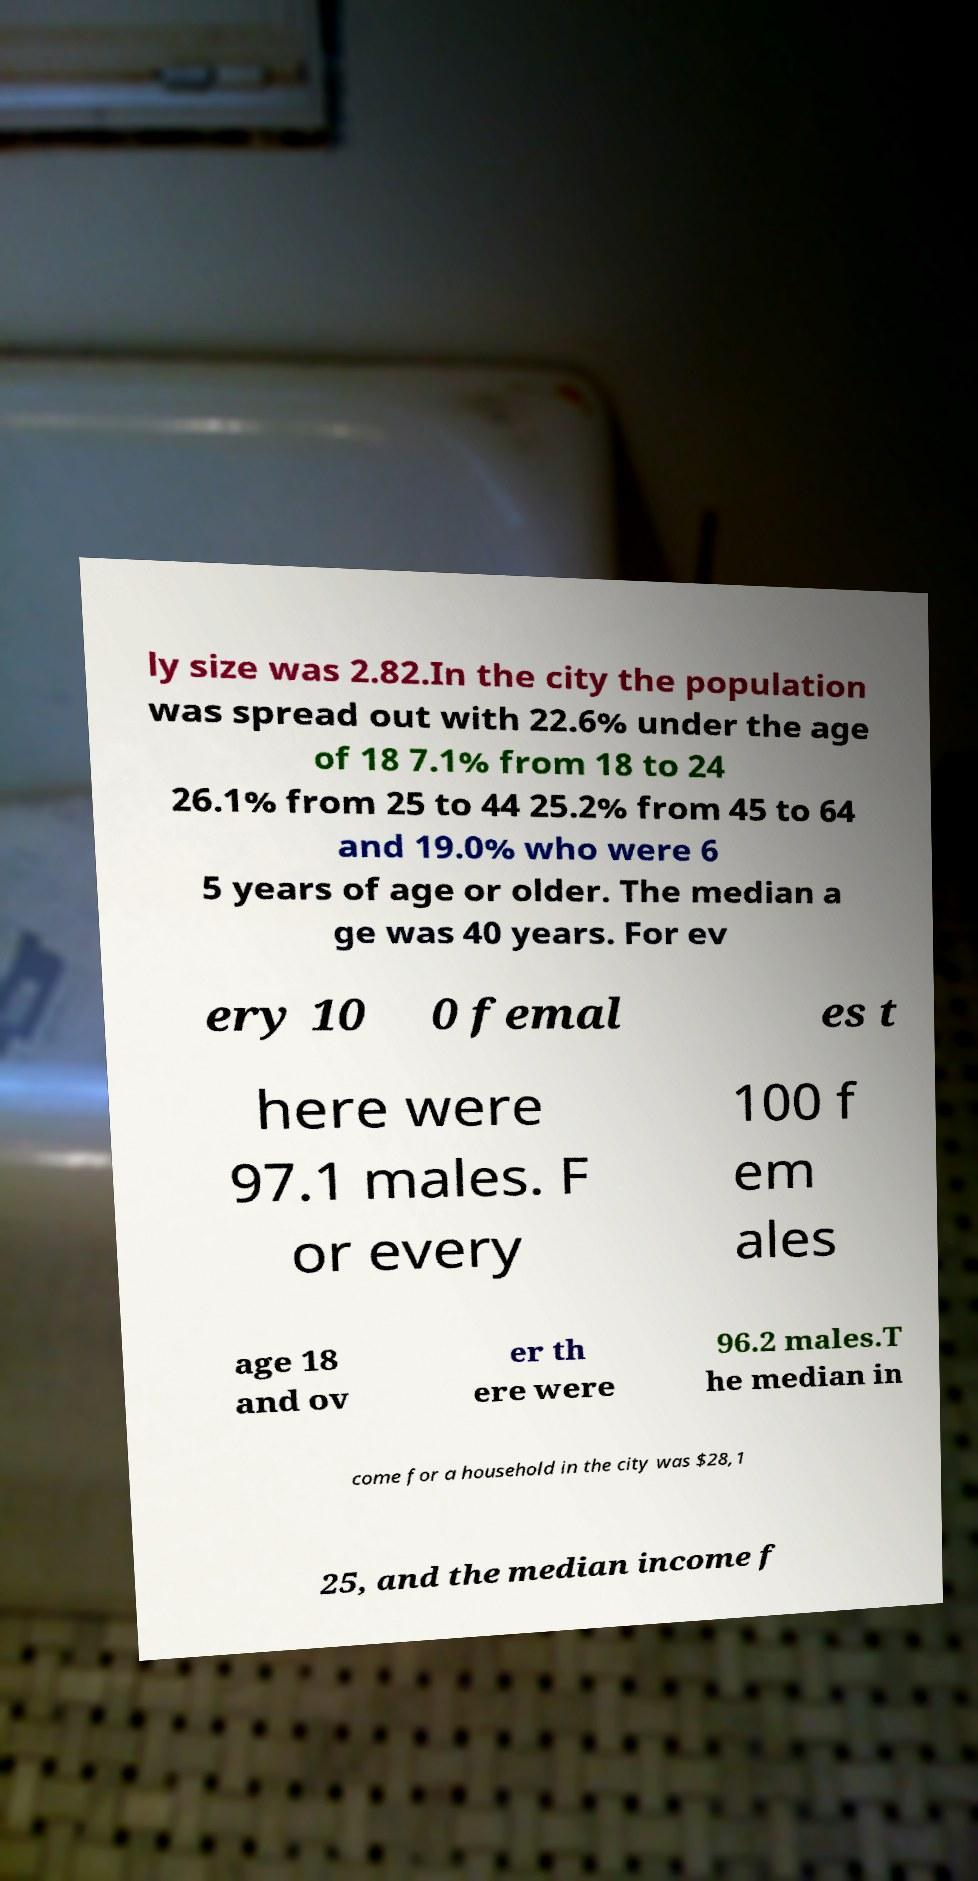Could you extract and type out the text from this image? ly size was 2.82.In the city the population was spread out with 22.6% under the age of 18 7.1% from 18 to 24 26.1% from 25 to 44 25.2% from 45 to 64 and 19.0% who were 6 5 years of age or older. The median a ge was 40 years. For ev ery 10 0 femal es t here were 97.1 males. F or every 100 f em ales age 18 and ov er th ere were 96.2 males.T he median in come for a household in the city was $28,1 25, and the median income f 